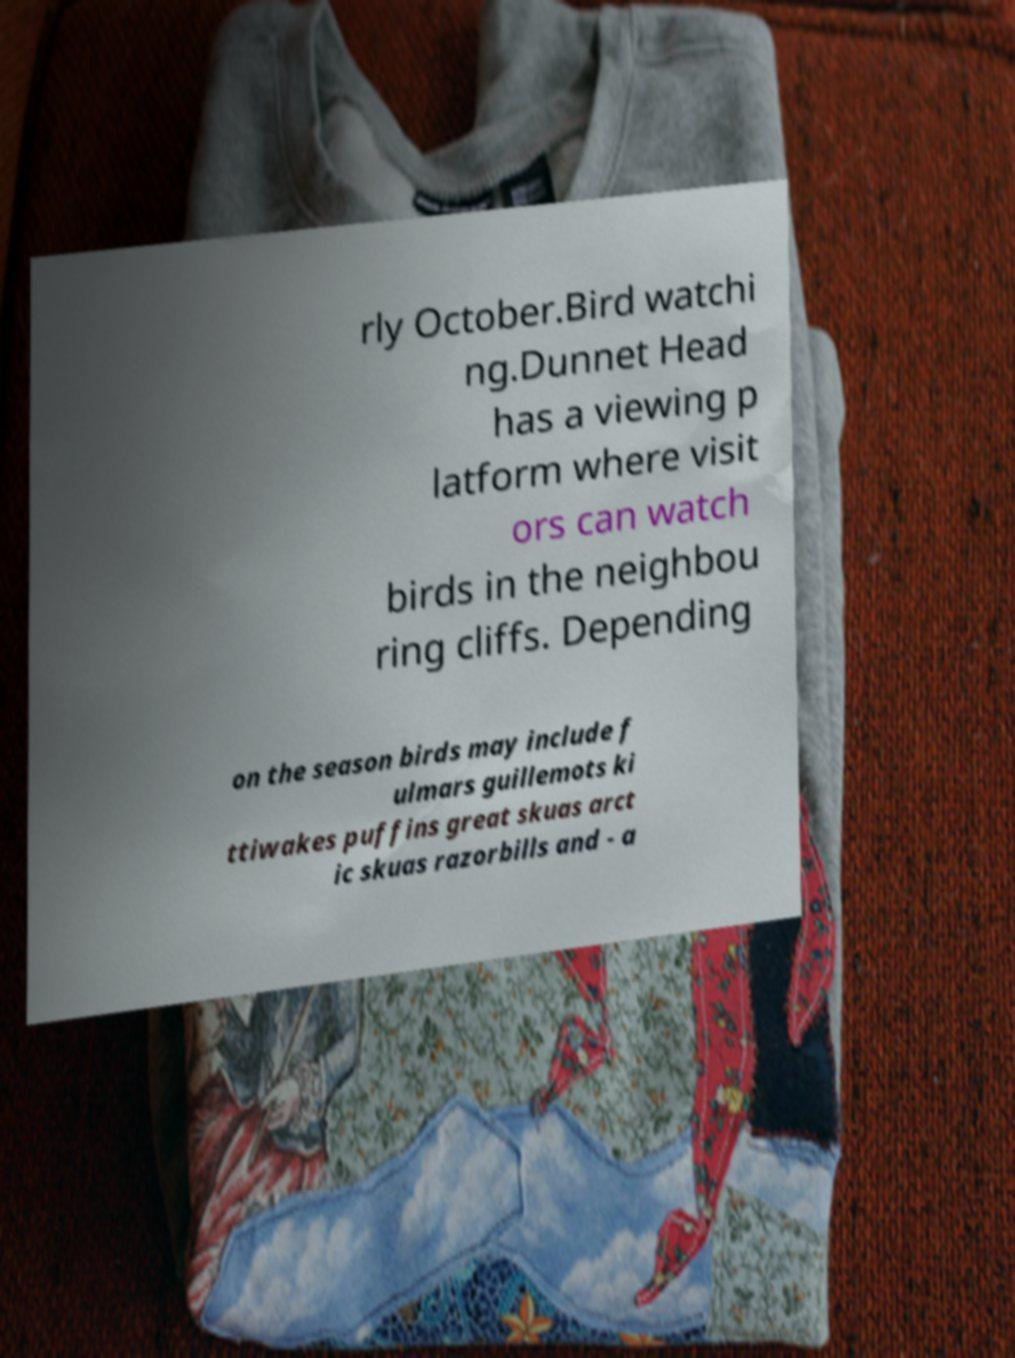Can you read and provide the text displayed in the image?This photo seems to have some interesting text. Can you extract and type it out for me? rly October.Bird watchi ng.Dunnet Head has a viewing p latform where visit ors can watch birds in the neighbou ring cliffs. Depending on the season birds may include f ulmars guillemots ki ttiwakes puffins great skuas arct ic skuas razorbills and - a 